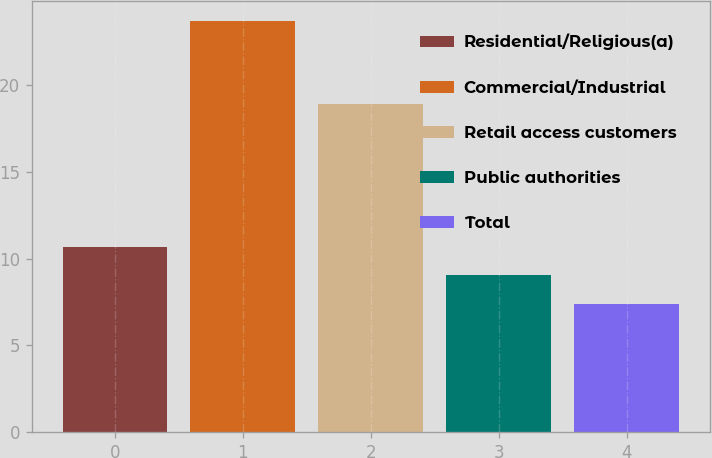Convert chart. <chart><loc_0><loc_0><loc_500><loc_500><bar_chart><fcel>Residential/Religious(a)<fcel>Commercial/Industrial<fcel>Retail access customers<fcel>Public authorities<fcel>Total<nl><fcel>10.66<fcel>23.7<fcel>18.9<fcel>9.03<fcel>7.4<nl></chart> 